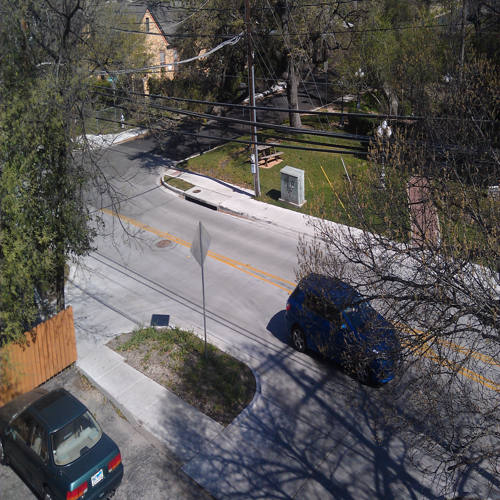Can you describe the setting or location depicted in this image? The image depicts a suburban setting with residential housing. There's a paved street with cars parked alongside and a visible street sign, suggesting a typical neighborhood scene possibly within a town or city suburb. What time of year does it appear to be in the image? Judging by the leafless trees and the absence of snow, it seems to be either late autumn or early spring. The sunny weather and lack of people suggest a quiet, possibly midday scene. 